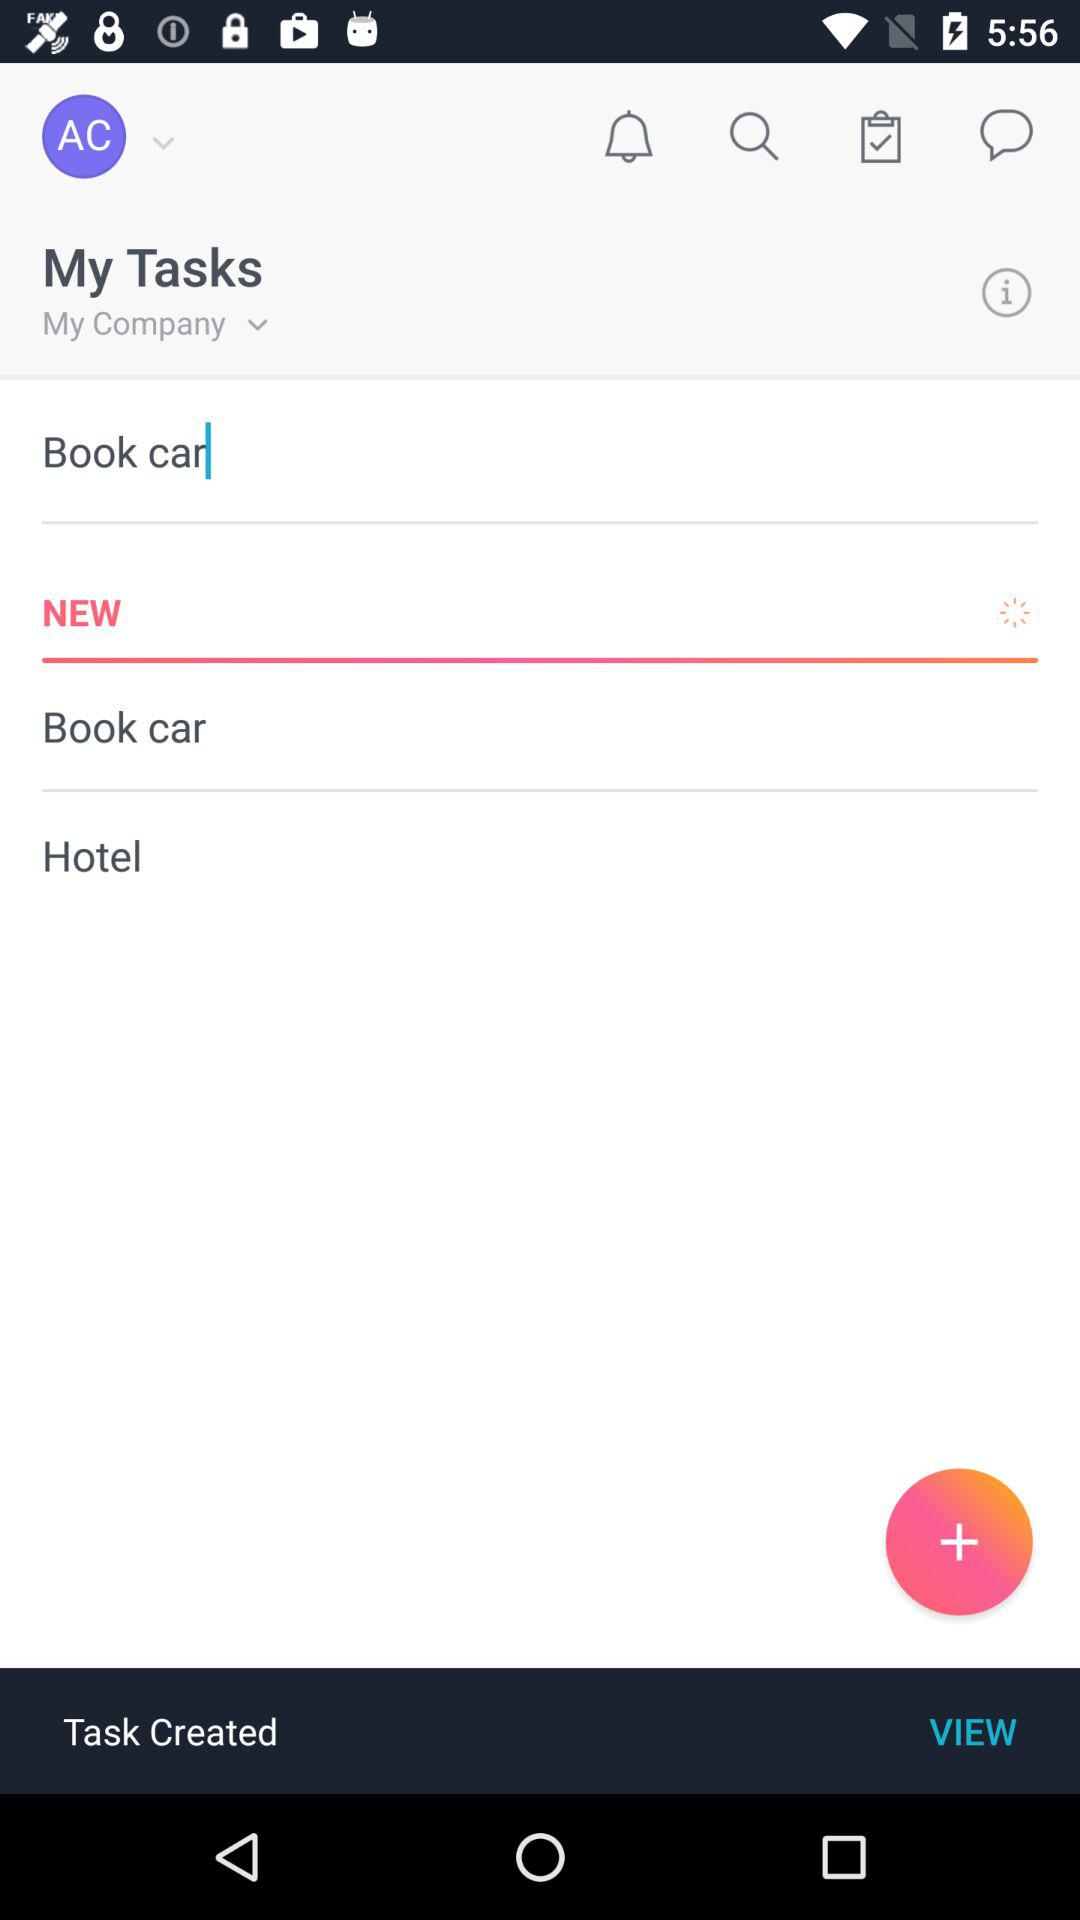Show me the list of task I have created?
When the provided information is insufficient, respond with <no answer>. <no answer> 